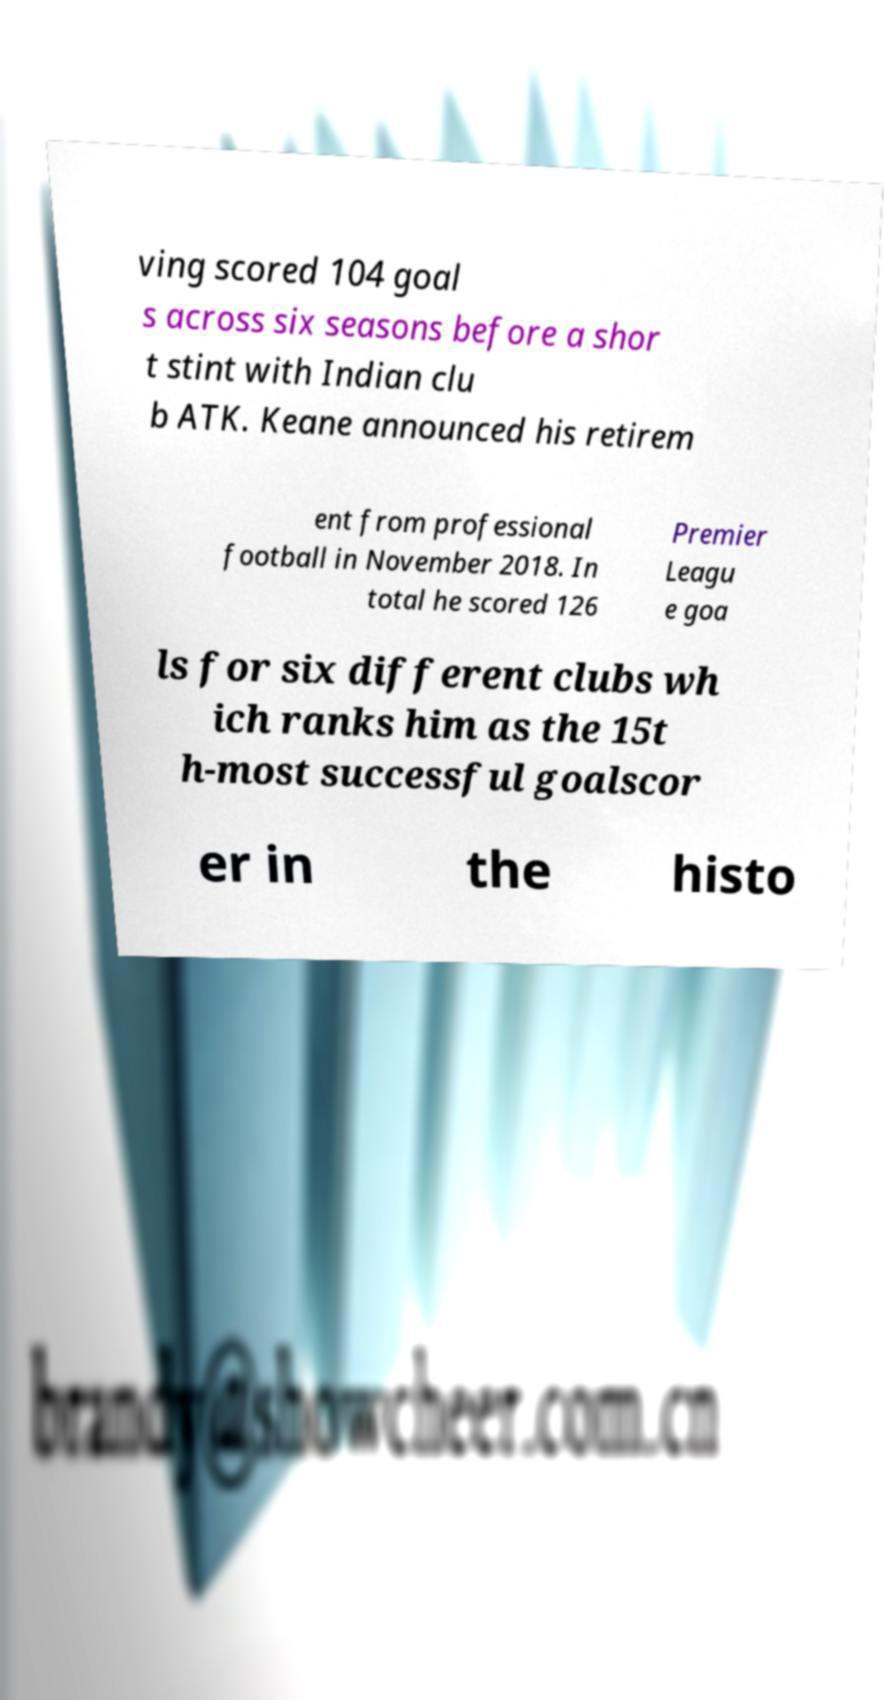Could you extract and type out the text from this image? ving scored 104 goal s across six seasons before a shor t stint with Indian clu b ATK. Keane announced his retirem ent from professional football in November 2018. In total he scored 126 Premier Leagu e goa ls for six different clubs wh ich ranks him as the 15t h-most successful goalscor er in the histo 